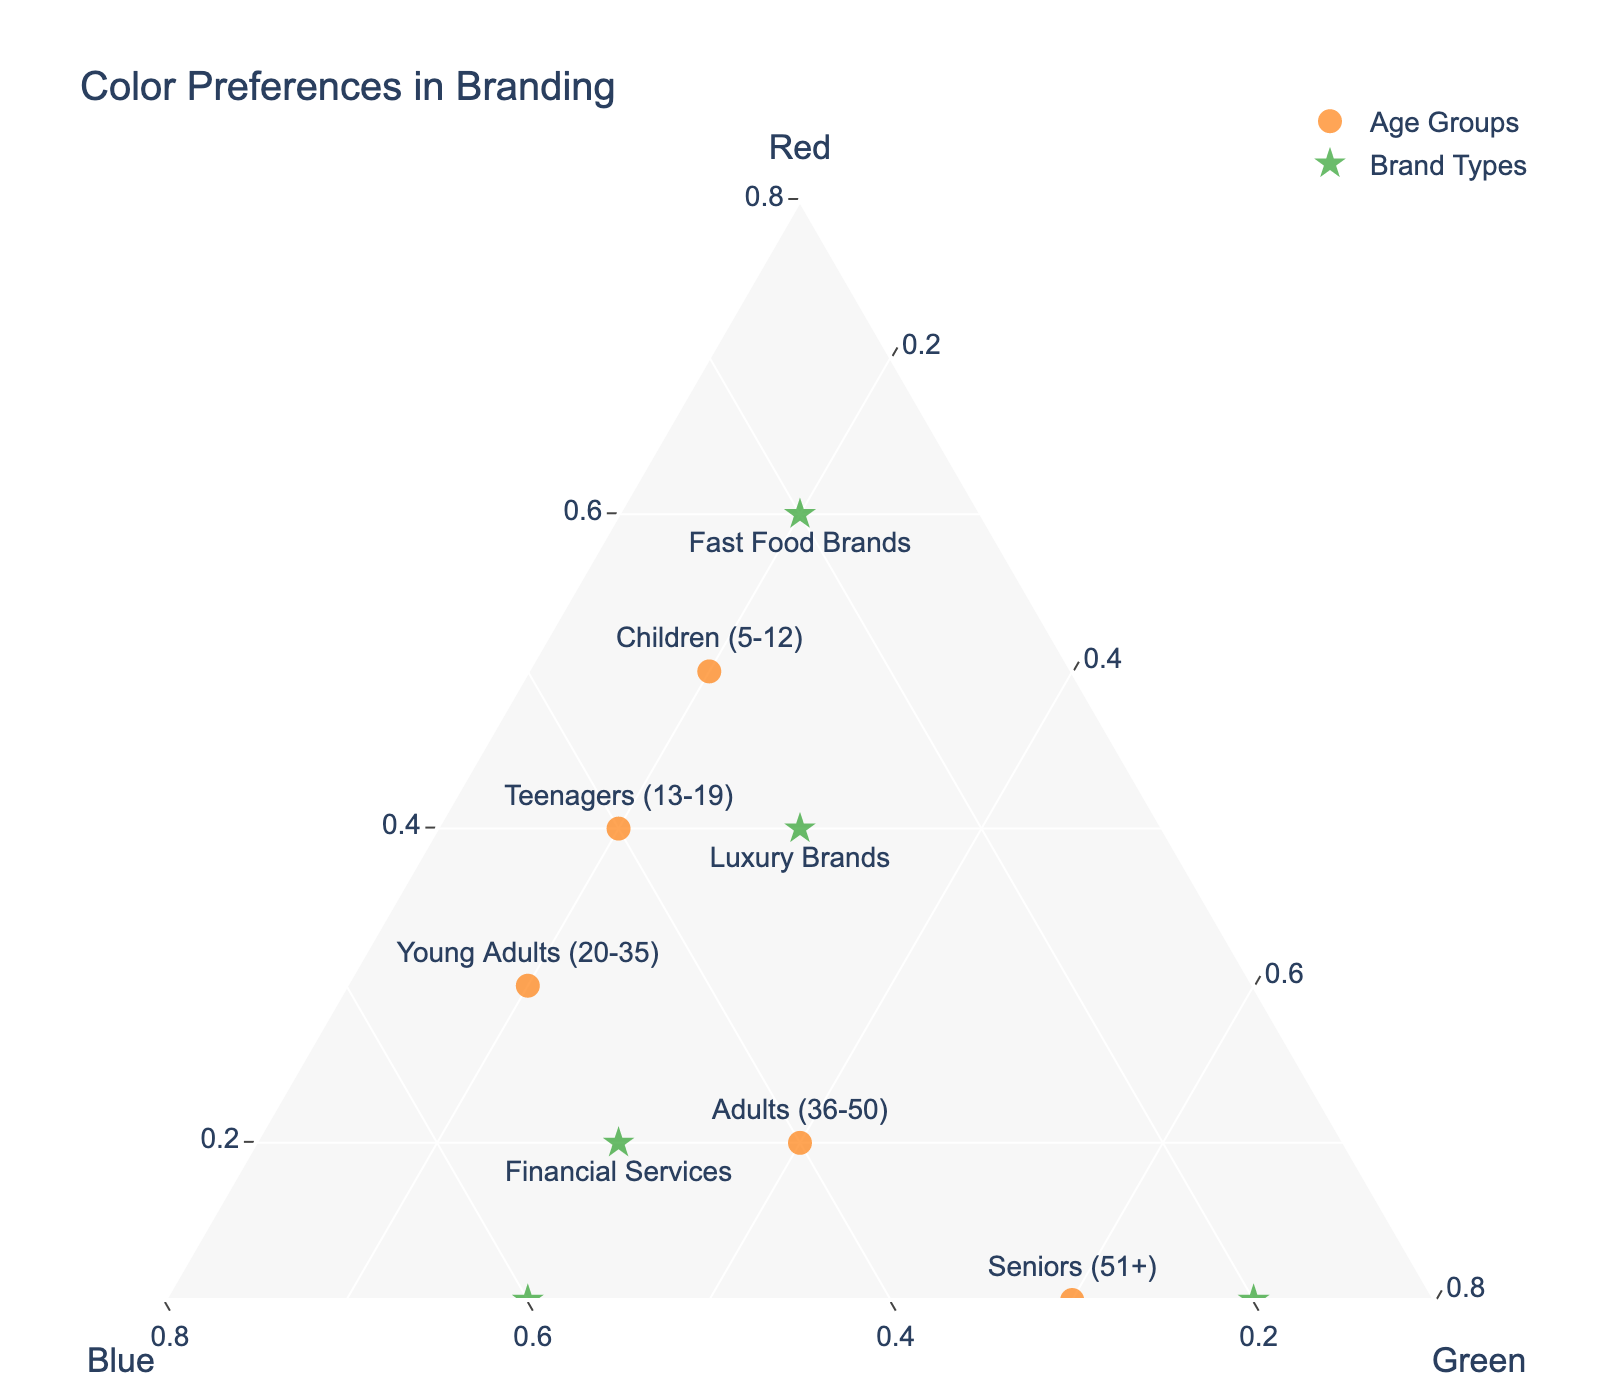What does the title of the plot say? The title is at the top of the plot. By reading it, we understand the focus of the figure.
Answer: Color Preferences in Branding How many age groups are represented in the plot? The age group data points are denoted with circular markers with a label. By counting these markers, we find the number of age groups.
Answer: 5 Which age group shows the highest preference for Green? We need to locate the age group markers and check the 'Green' axis values. The age group closest to 1 on the 'Green' axis has the highest preference for Green.
Answer: Seniors (51+) How do preferences for Red compare between Teenagers and Financial Services? We need to look at the Red axis coordinates for both Teenagers and Financial Services. Teenagers are at 0.4, and Financial Services are at 0.2 on the Red axis. Therefore, Teenagers prefer Red more.
Answer: Teenagers prefer more Which brands show similar preferences to Children (5-12) for Blue? Locate the Blue axis value for Children (5-12) and find brands with close coordinates. Children (5-12) are at 0.3 for Blue.
Answer: No brands are exactly at 0.3, but Luxury Brands (0.3) are closest What is the average value of Red for Children, Teenagers, and Young Adults? Locate the Red axis values for these age groups (0.5, 0.4, 0.3 respectively), then sum these values and divide by the number of groups (3). Calculation: (0.5+0.4+0.3)/3 = 1.2/3 = 0.4
Answer: 0.4 Which brand shows the highest preference for Blue? Locate the Blue axis values for all the brands and find the one with the highest value. Tech Companies are at 0.6, which is higher than the others.
Answer: Tech Companies Which age group has a balanced preference for all three colors (Red, Blue, Green)? A balanced preference would be when an age group is equidistant from each axis, indicating similar proportions. Adults (36-50) have values of 0.2 (Red), 0.4 (Blue), 0.4 (Green), closest to balanced.
Answer: Adults (36-50) Does any age group have the same preference proportions for all three colors as Eco-Friendly Products? Check if any age group has Red, Blue, and Green proportions (0.1, 0.2, 0.7) matching Eco-Friendly Products.
Answer: No 